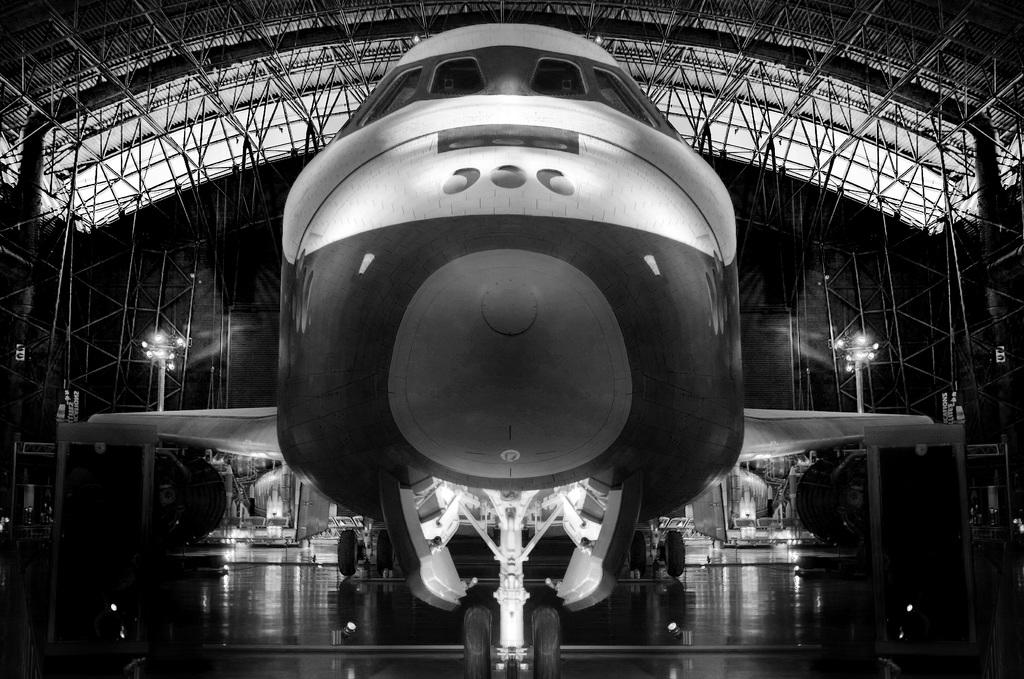What type of objects are visible in the image? There are lights, a shed, and a fence in the image. Can you describe the other objects present in the image? There are some other objects in the image, but their specific details are not mentioned in the provided facts. Is there a laborer working on the shed in the image? There is no mention of a laborer or any work being done on the shed in the provided facts. What impulse might have led to the placement of the lights in the image? The provided facts do not mention any impulse or reason for the placement of the lights; they only state that there are lights in the image. 